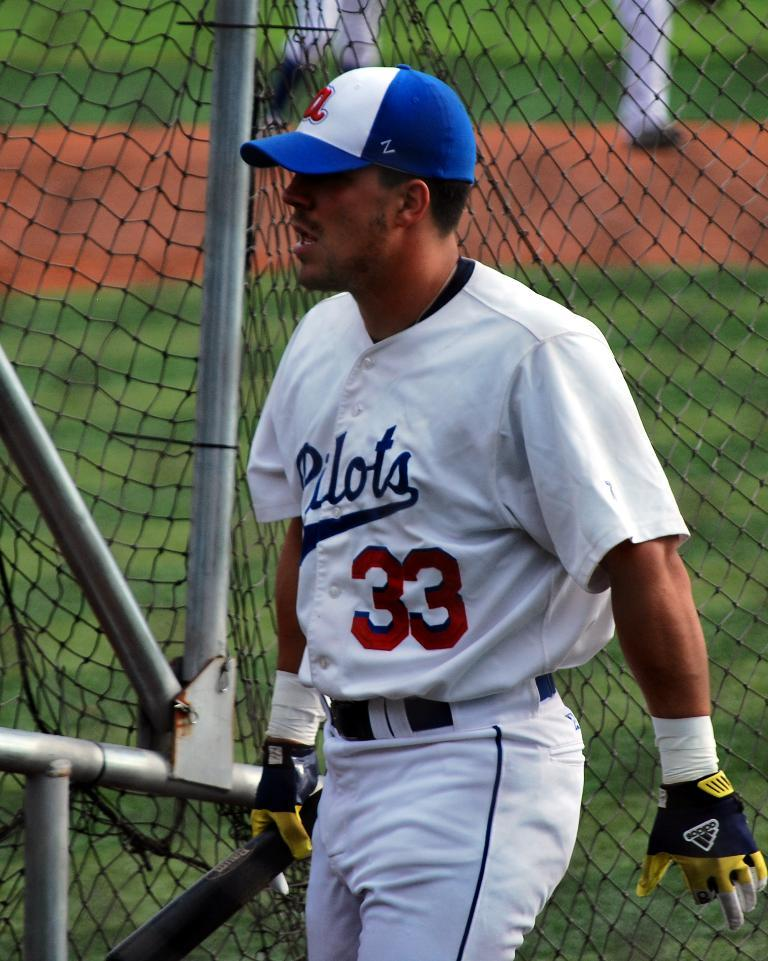<image>
Offer a succinct explanation of the picture presented. A male baseball player with number 33 from the Pilots. 